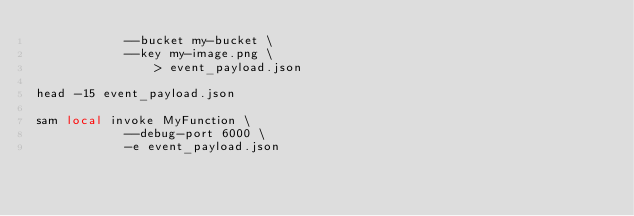<code> <loc_0><loc_0><loc_500><loc_500><_Bash_>            --bucket my-bucket \
            --key my-image.png \
                > event_payload.json

head -15 event_payload.json

sam local invoke MyFunction \
            --debug-port 6000 \
            -e event_payload.json</code> 